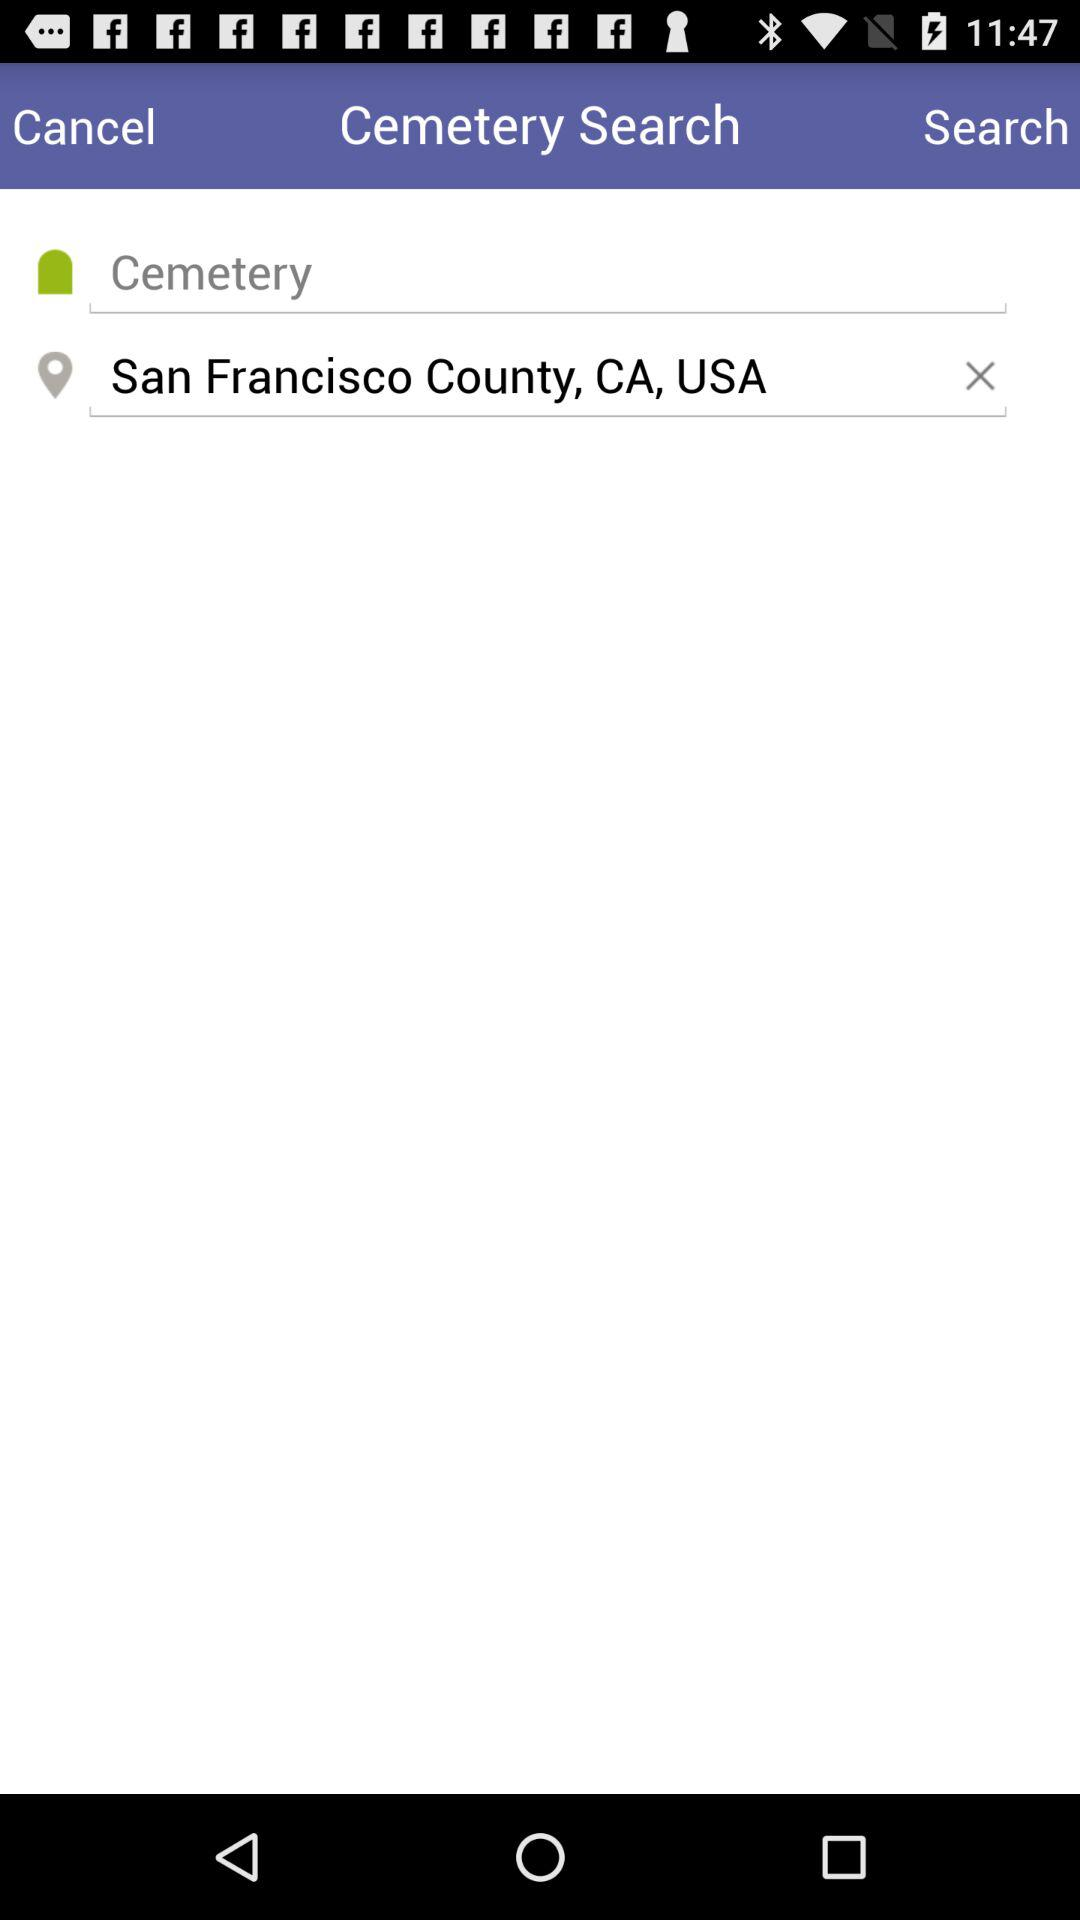What is the name of the cemetery?
When the provided information is insufficient, respond with <no answer>. <no answer> 